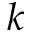Convert formula to latex. <formula><loc_0><loc_0><loc_500><loc_500>k</formula> 